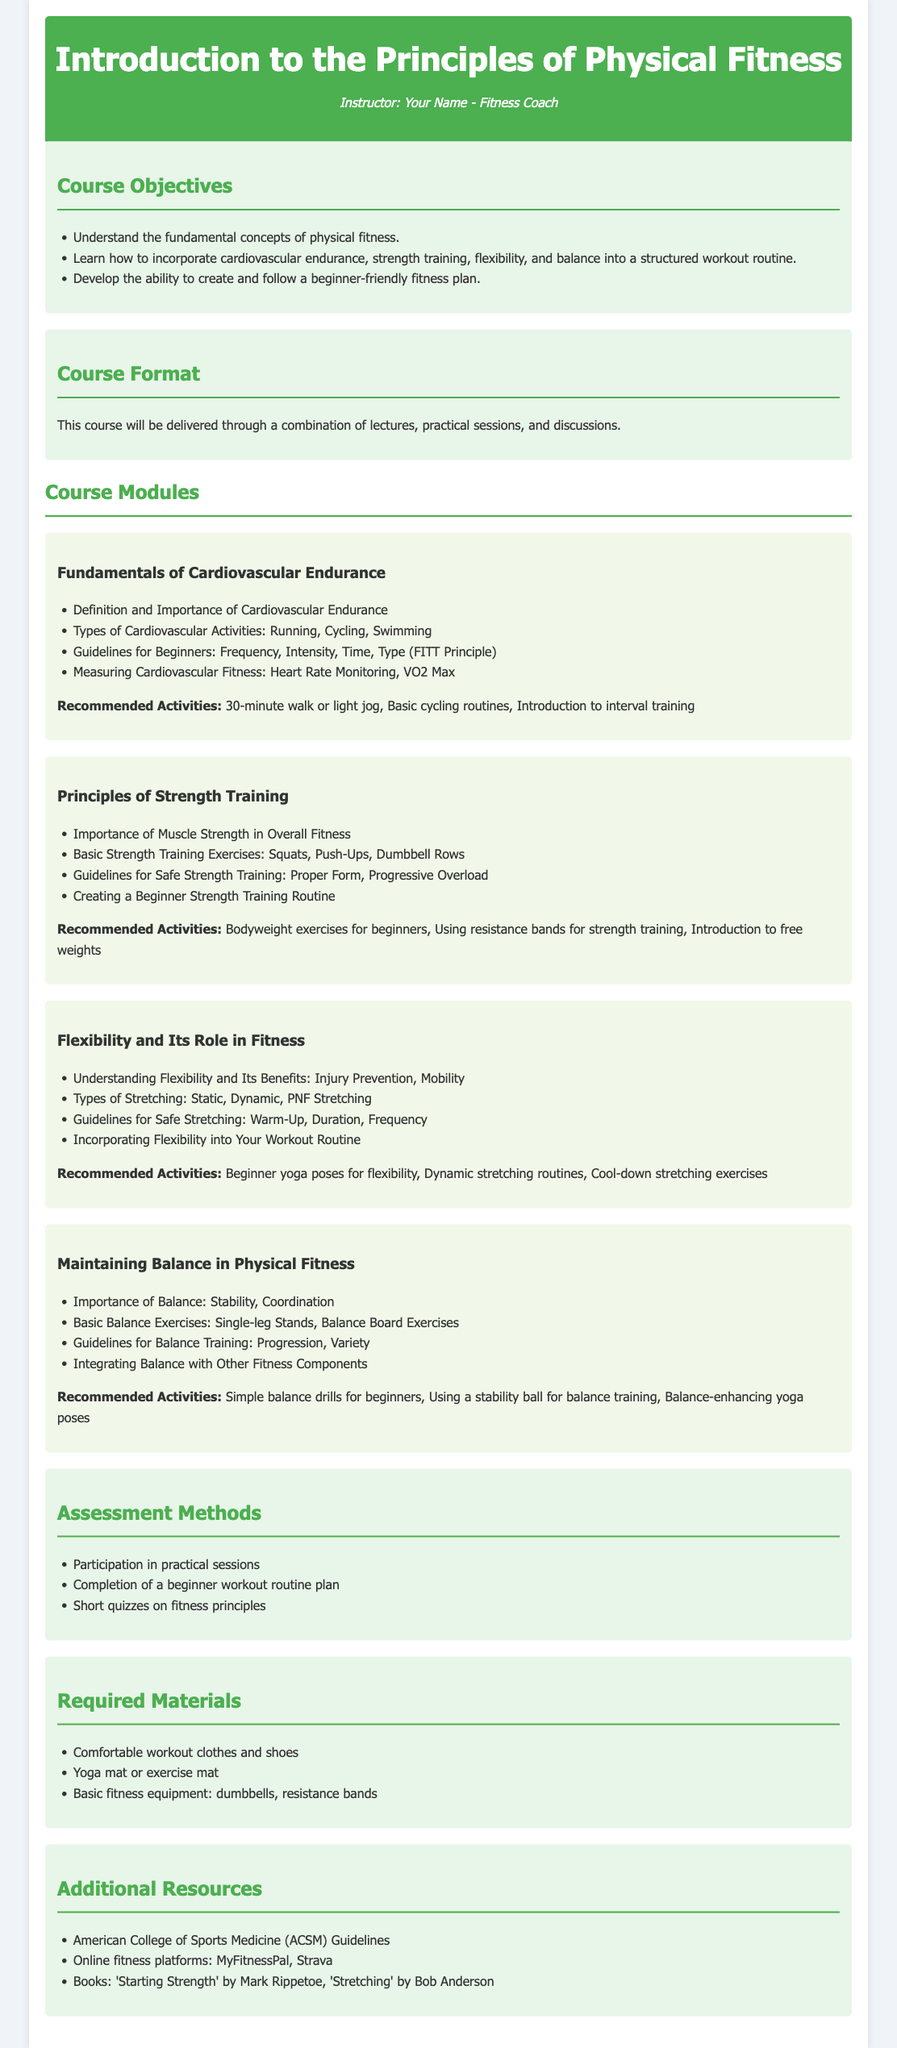What are the course objectives? The document lists three course objectives that encompass understanding physical fitness concepts and developing fitness plans.
Answer: Understand the fundamental concepts of physical fitness, Learn how to incorporate cardiovascular endurance, strength training, flexibility, and balance into a structured workout routine, Develop the ability to create and follow a beginner-friendly fitness plan What types of cardiovascular activities are mentioned? The syllabus details various types of cardiovascular activities to improve endurance.
Answer: Running, Cycling, Swimming What is the FITT principle? The document references the FITT principle in the context of guidelines for beginners to help structure their cardiovascular training.
Answer: Frequency, Intensity, Time, Type Which exercises are included in basic strength training? The syllabus outlines specific basic strength training exercises as part of the strength training principles.
Answer: Squats, Push-Ups, Dumbbell Rows What is one recommended activity for flexibility training? The document suggests activities specifically targeting flexibility improvement.
Answer: Beginner yoga poses for flexibility How will the course be delivered? The format section outlines how the course will be conducted, explaining the delivery method.
Answer: Combination of lectures, practical sessions, and discussions What are the required materials for the course? This section lists materials that participants must have for the course.
Answer: Comfortable workout clothes and shoes, Yoga mat or exercise mat, Basic fitness equipment: dumbbells, resistance bands What types of stretching are discussed in the syllabus? The syllabus includes different types of stretching relevant to the fitness principles taught.
Answer: Static, Dynamic, PNF Stretching 